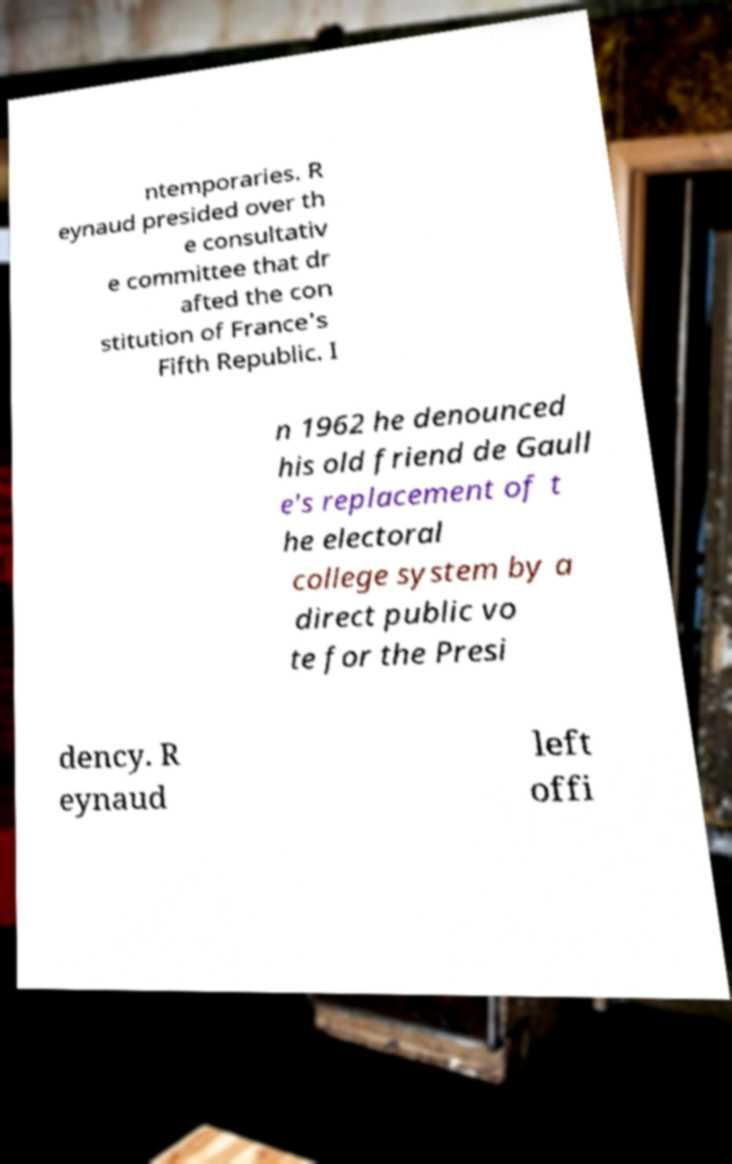There's text embedded in this image that I need extracted. Can you transcribe it verbatim? ntemporaries. R eynaud presided over th e consultativ e committee that dr afted the con stitution of France's Fifth Republic. I n 1962 he denounced his old friend de Gaull e's replacement of t he electoral college system by a direct public vo te for the Presi dency. R eynaud left offi 